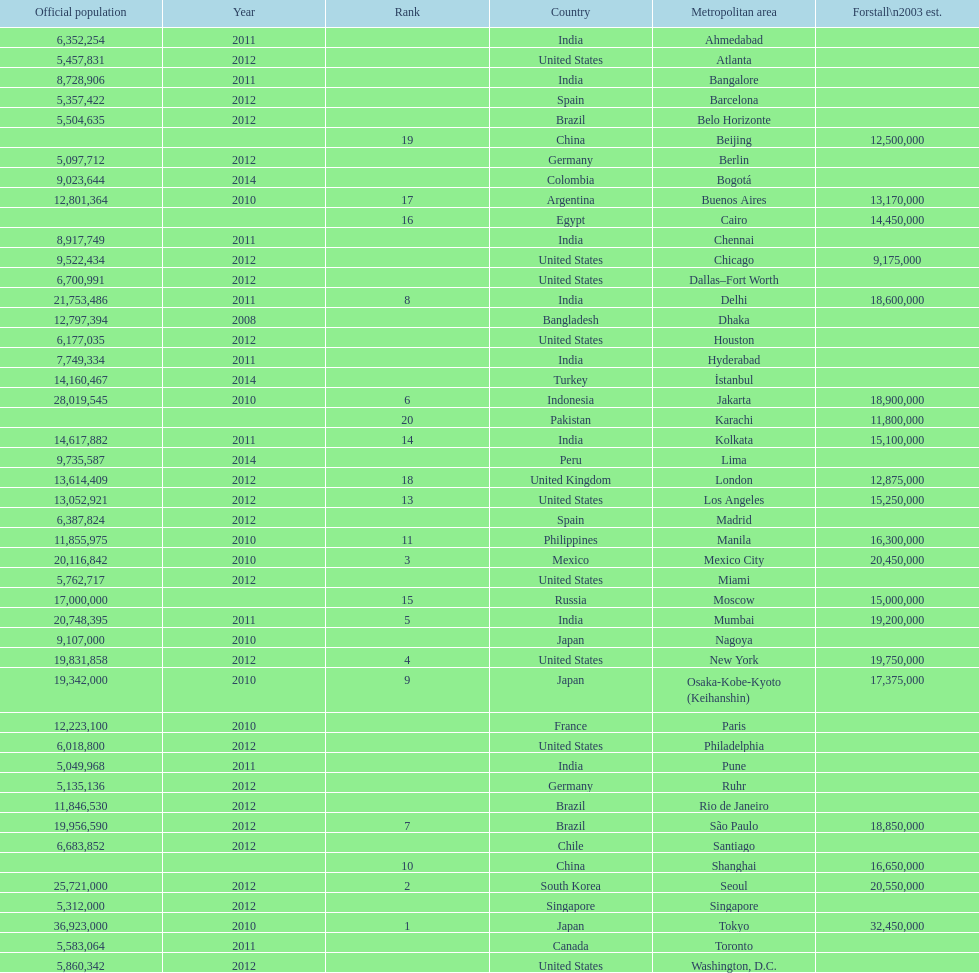Which population is listed before 5,357,422? 8,728,906. 